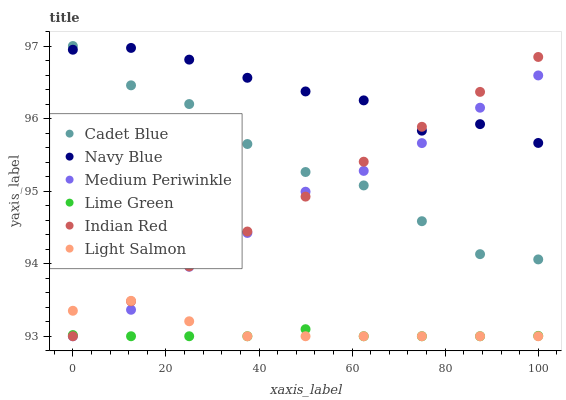Does Lime Green have the minimum area under the curve?
Answer yes or no. Yes. Does Navy Blue have the maximum area under the curve?
Answer yes or no. Yes. Does Cadet Blue have the minimum area under the curve?
Answer yes or no. No. Does Cadet Blue have the maximum area under the curve?
Answer yes or no. No. Is Indian Red the smoothest?
Answer yes or no. Yes. Is Cadet Blue the roughest?
Answer yes or no. Yes. Is Navy Blue the smoothest?
Answer yes or no. No. Is Navy Blue the roughest?
Answer yes or no. No. Does Light Salmon have the lowest value?
Answer yes or no. Yes. Does Cadet Blue have the lowest value?
Answer yes or no. No. Does Cadet Blue have the highest value?
Answer yes or no. Yes. Does Navy Blue have the highest value?
Answer yes or no. No. Is Lime Green less than Navy Blue?
Answer yes or no. Yes. Is Cadet Blue greater than Lime Green?
Answer yes or no. Yes. Does Lime Green intersect Light Salmon?
Answer yes or no. Yes. Is Lime Green less than Light Salmon?
Answer yes or no. No. Is Lime Green greater than Light Salmon?
Answer yes or no. No. Does Lime Green intersect Navy Blue?
Answer yes or no. No. 